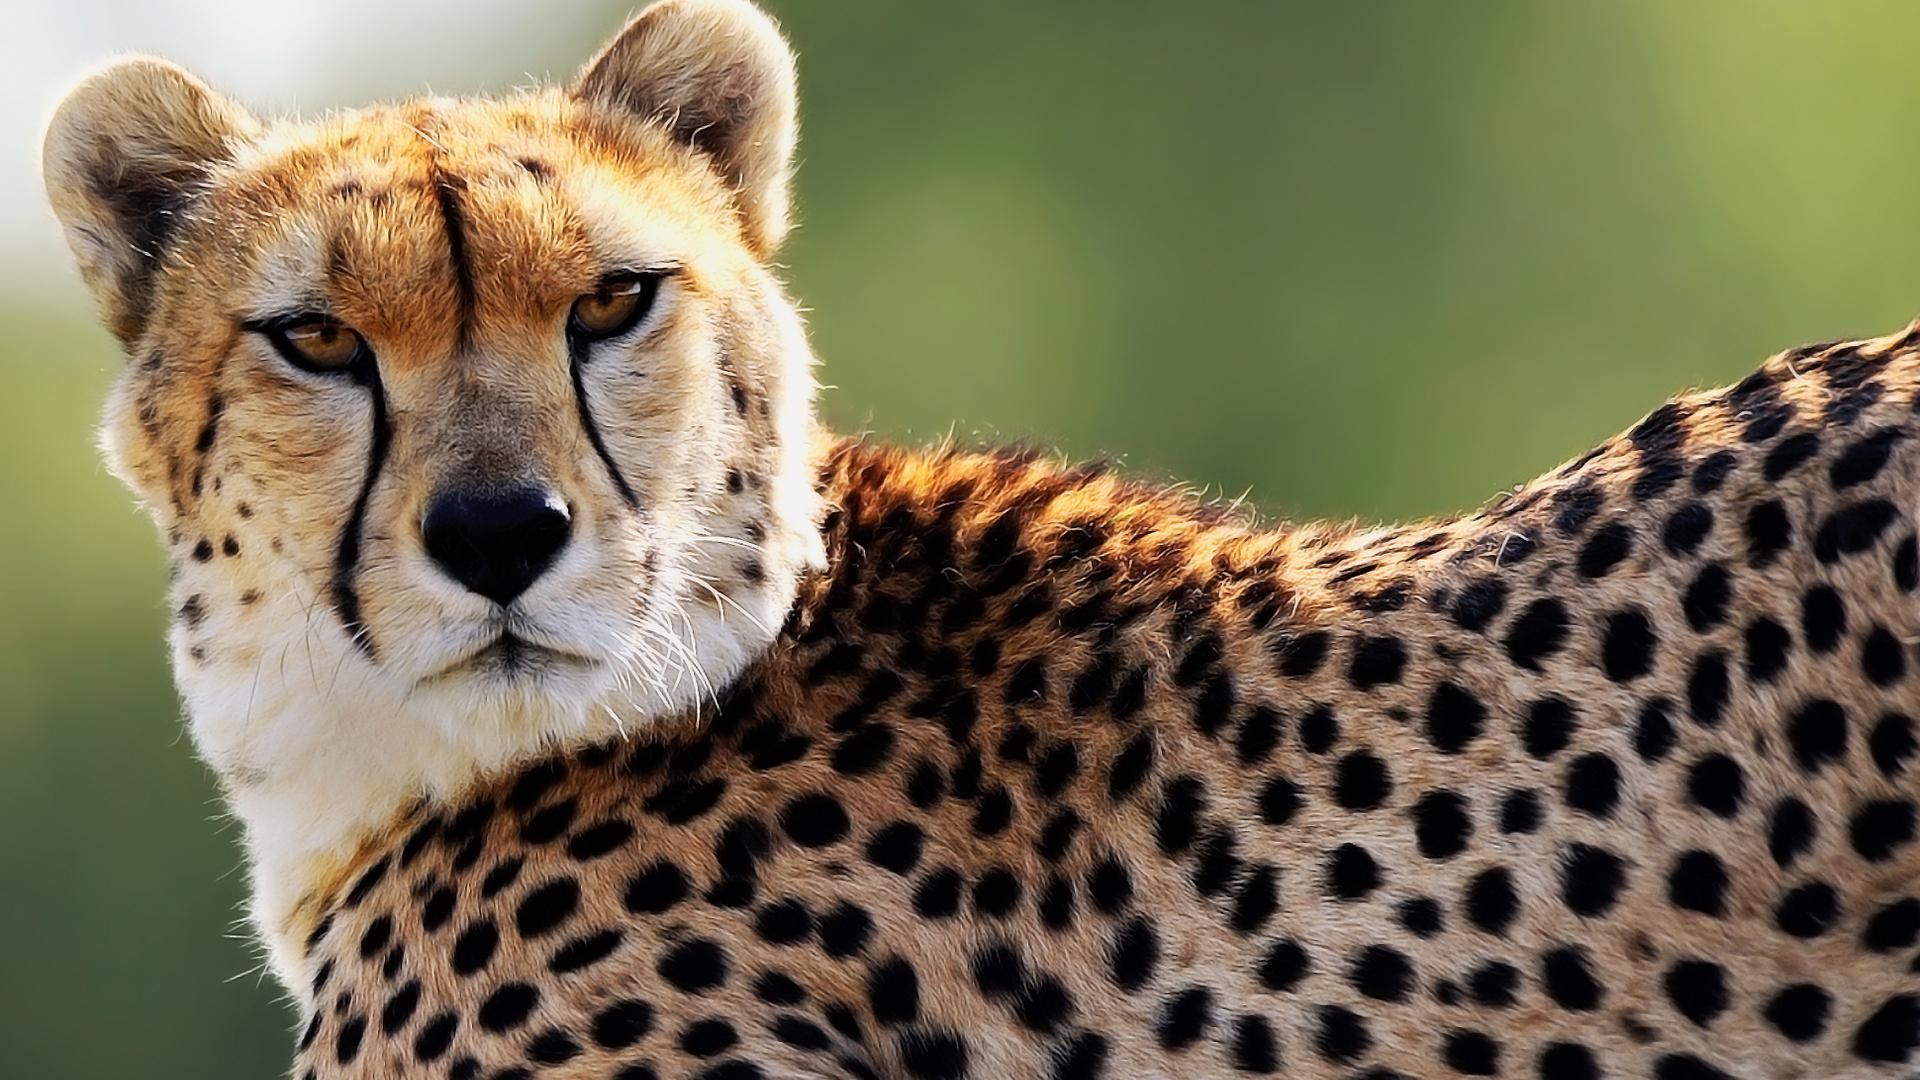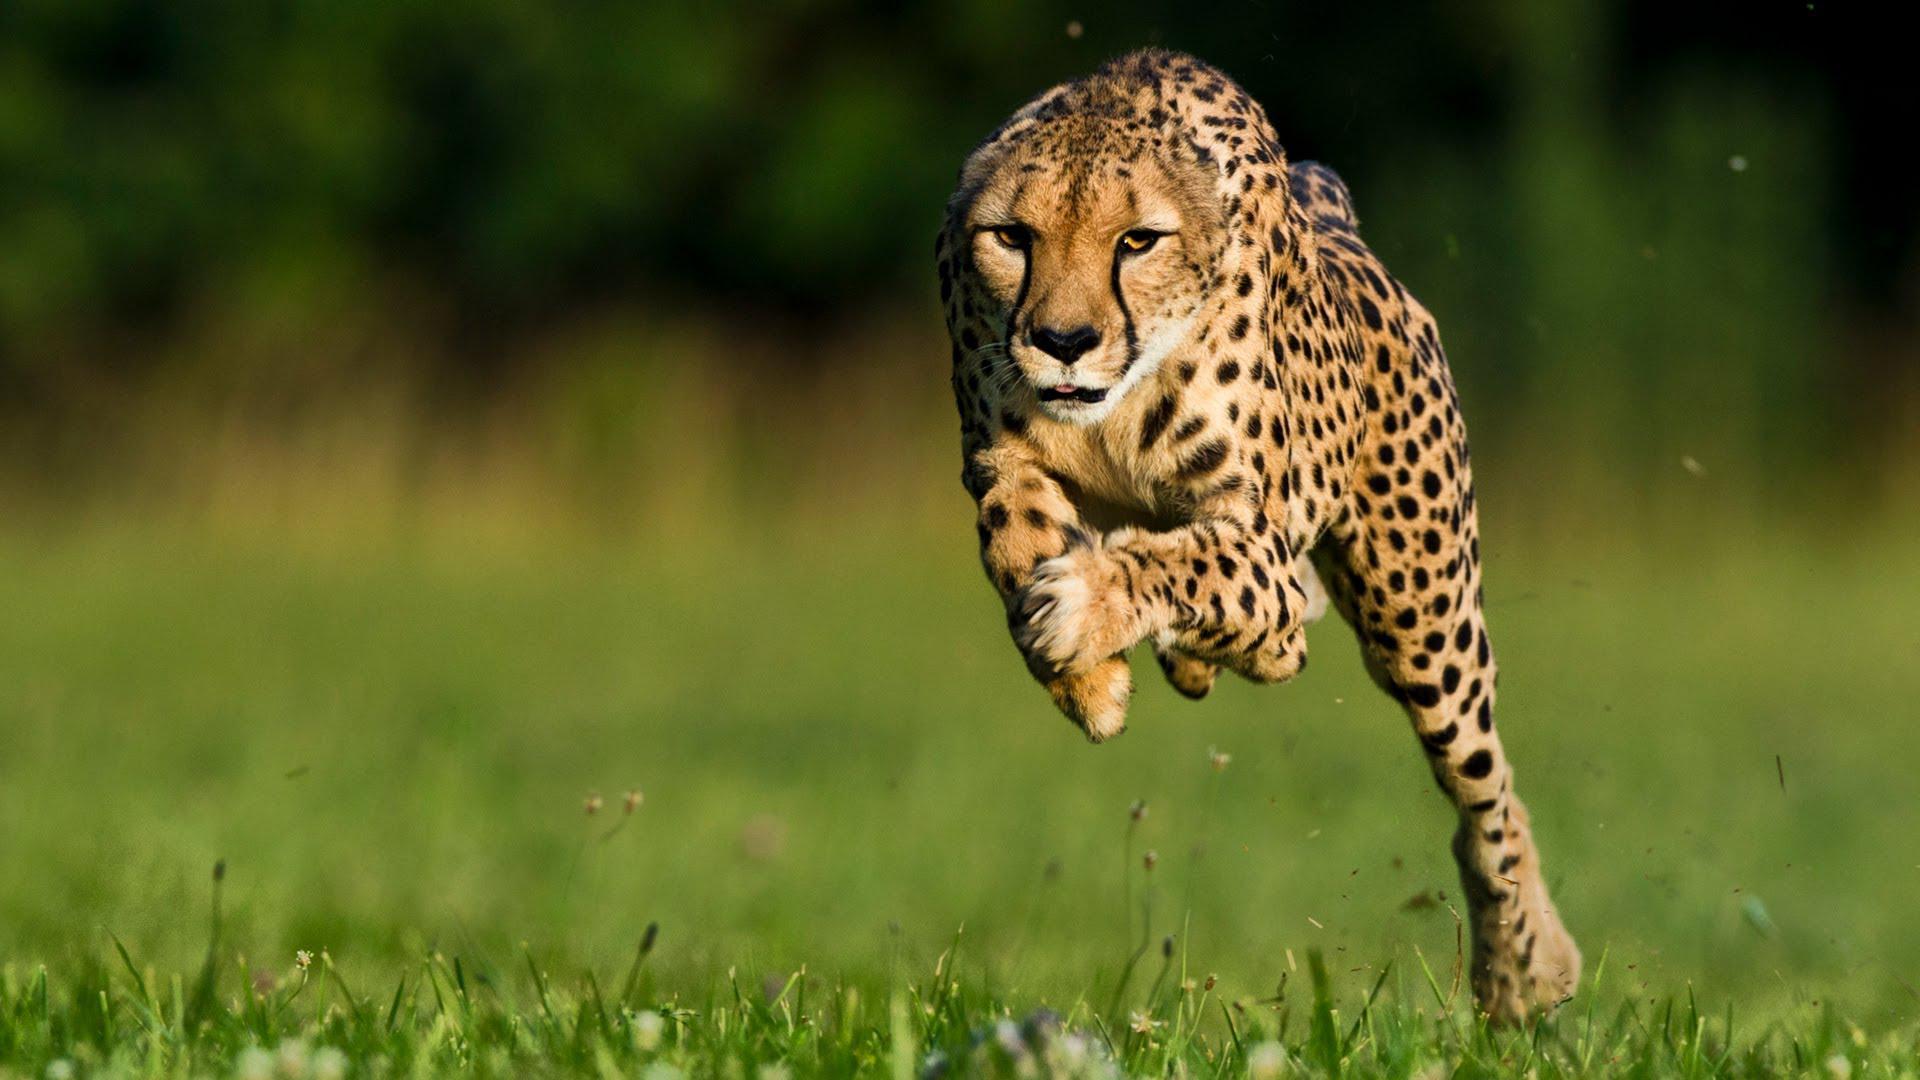The first image is the image on the left, the second image is the image on the right. Evaluate the accuracy of this statement regarding the images: "An image shows a cheetah bounding across the grass with front paws off the ground.". Is it true? Answer yes or no. Yes. The first image is the image on the left, the second image is the image on the right. For the images shown, is this caption "The left image contains at least two cheetahs." true? Answer yes or no. No. 